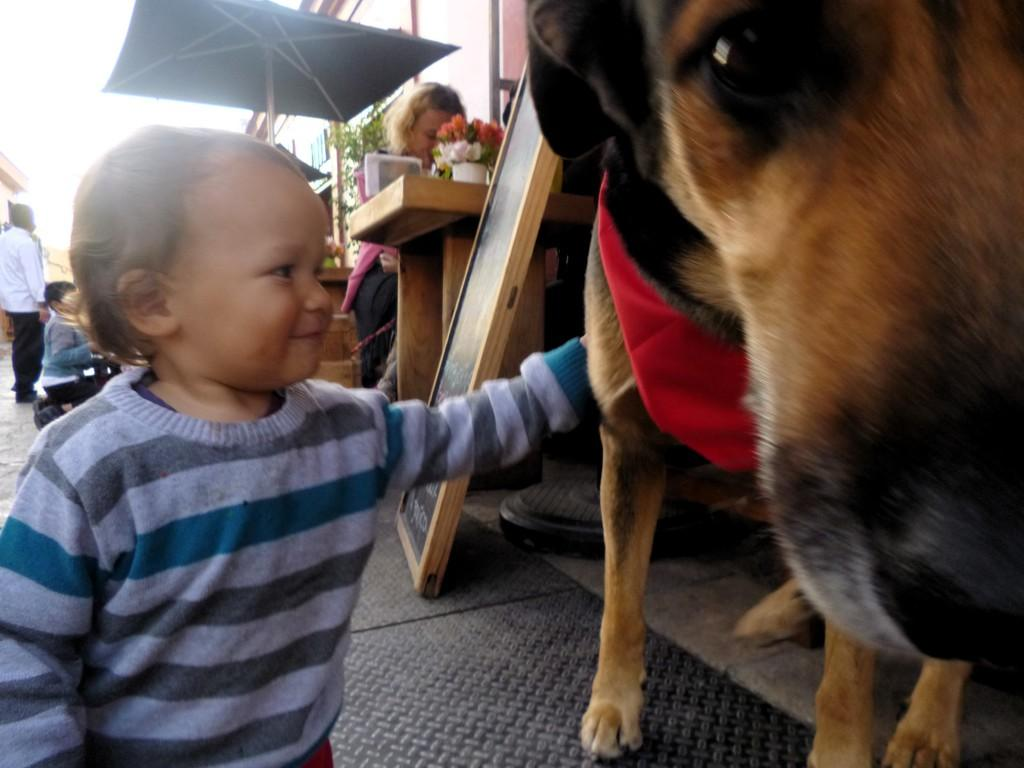Who is in the image? There is a boy in the image. What is the boy holding? The boy is holding a dog. What furniture is present in the image? There is a table and a chair in the image. What is on the table? There is a plant on the table. What type of fog can be seen in the image? There is no fog present in the image. 